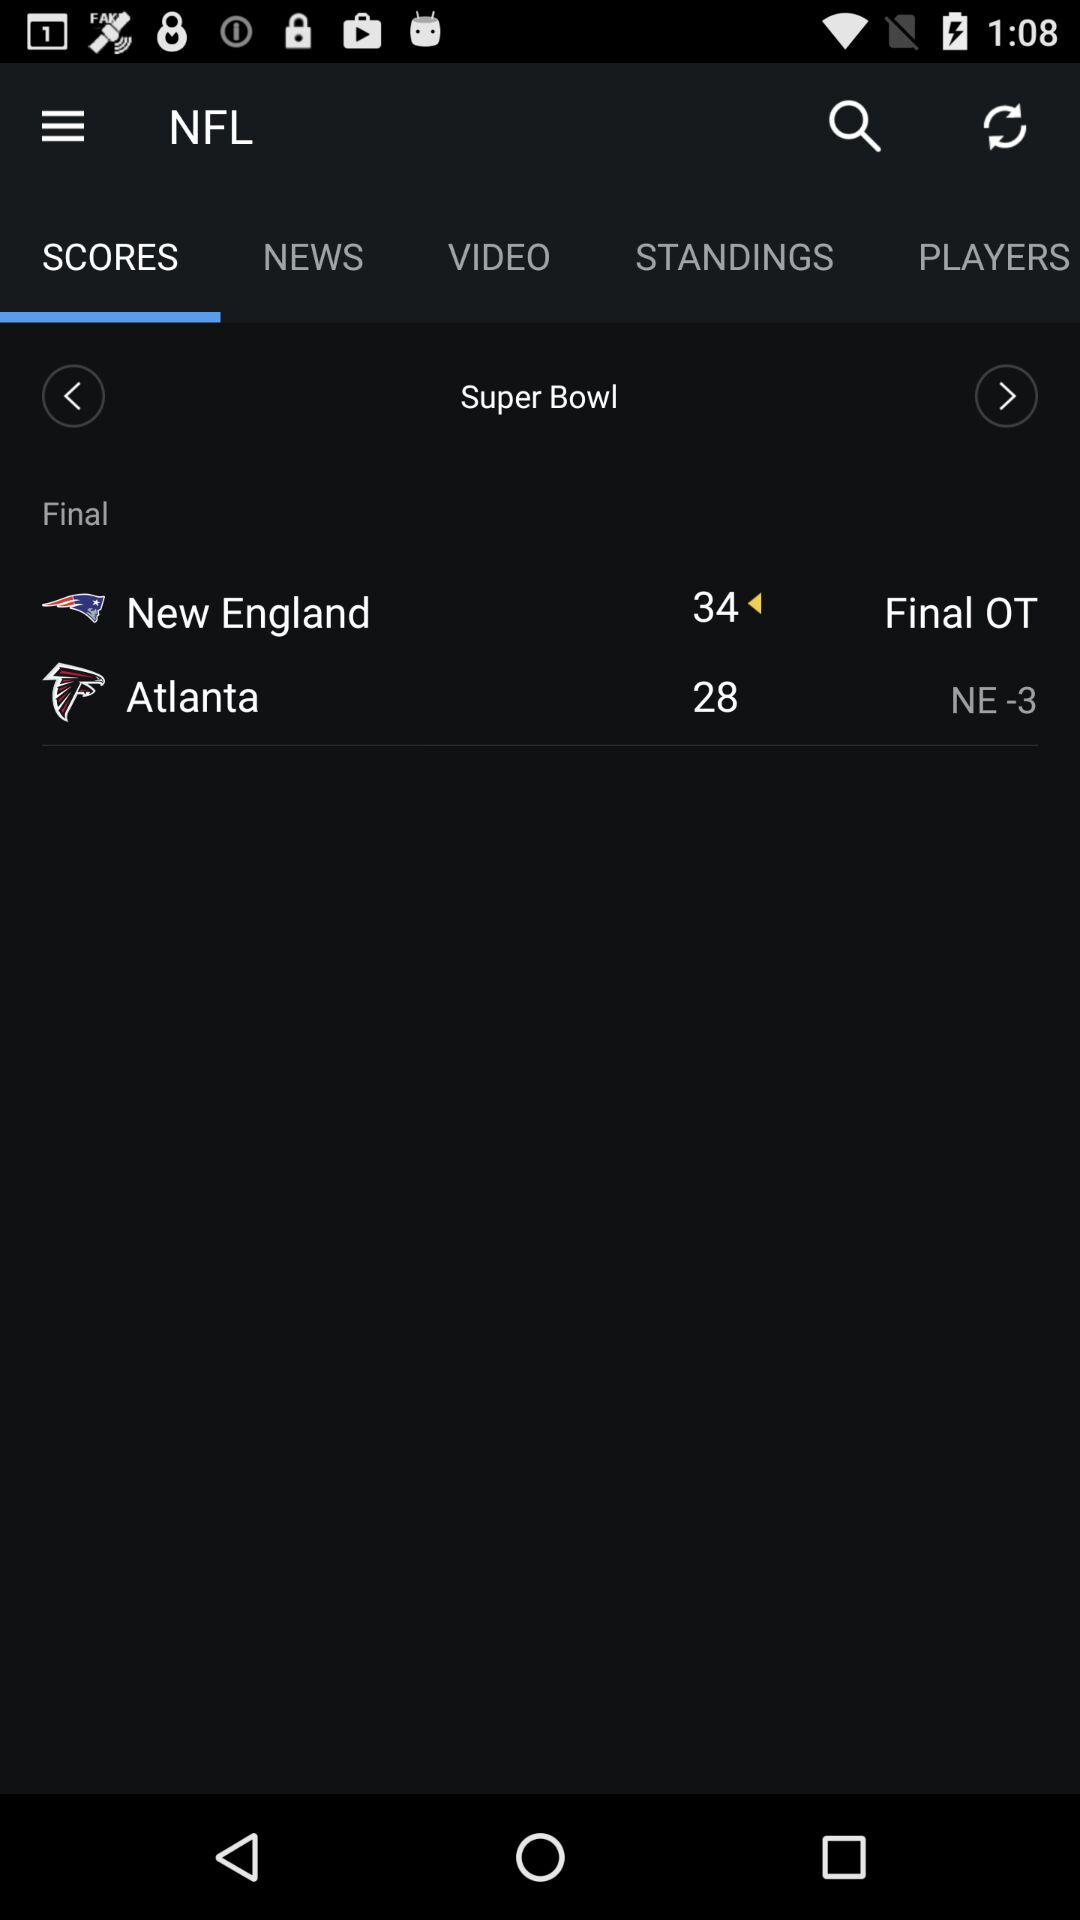What is the score for Atlanta? The score for Atlanta is 28. 